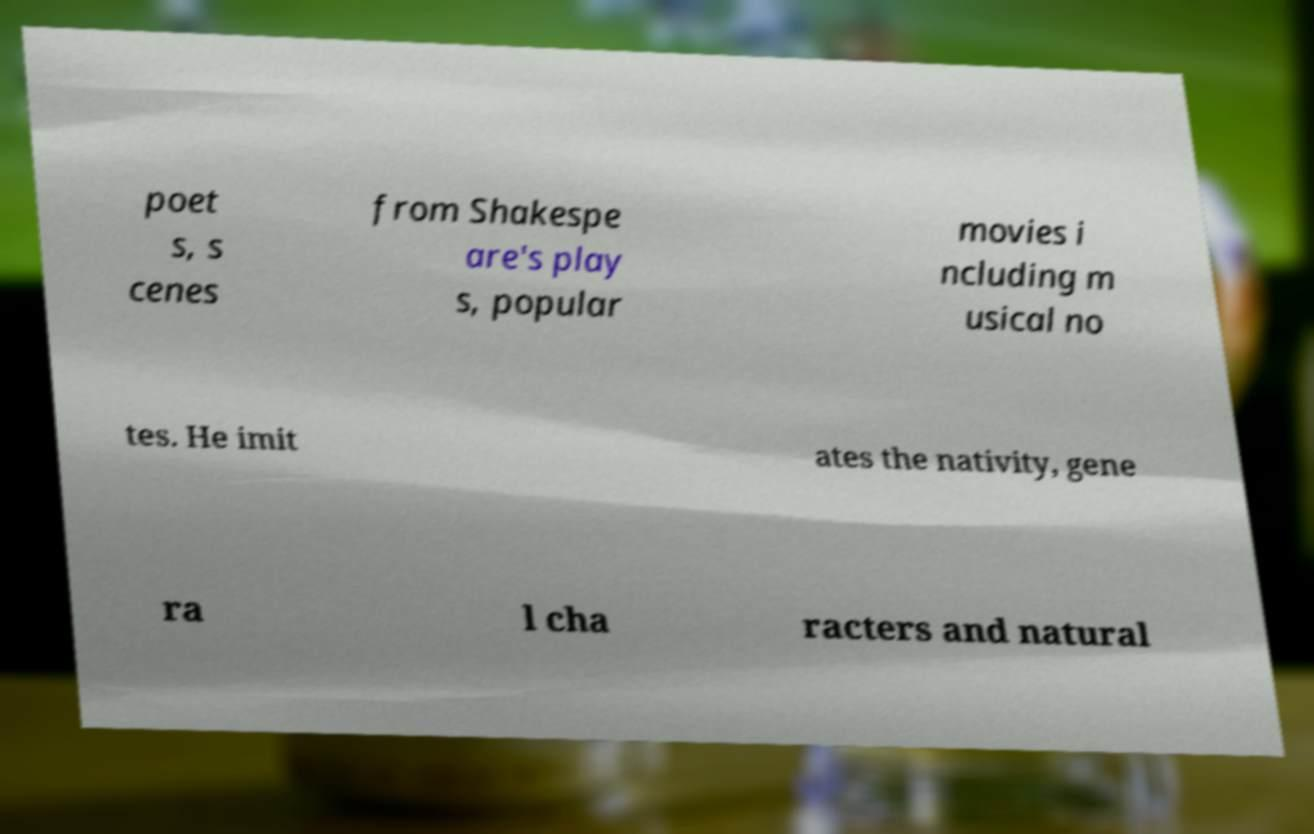There's text embedded in this image that I need extracted. Can you transcribe it verbatim? poet s, s cenes from Shakespe are's play s, popular movies i ncluding m usical no tes. He imit ates the nativity, gene ra l cha racters and natural 